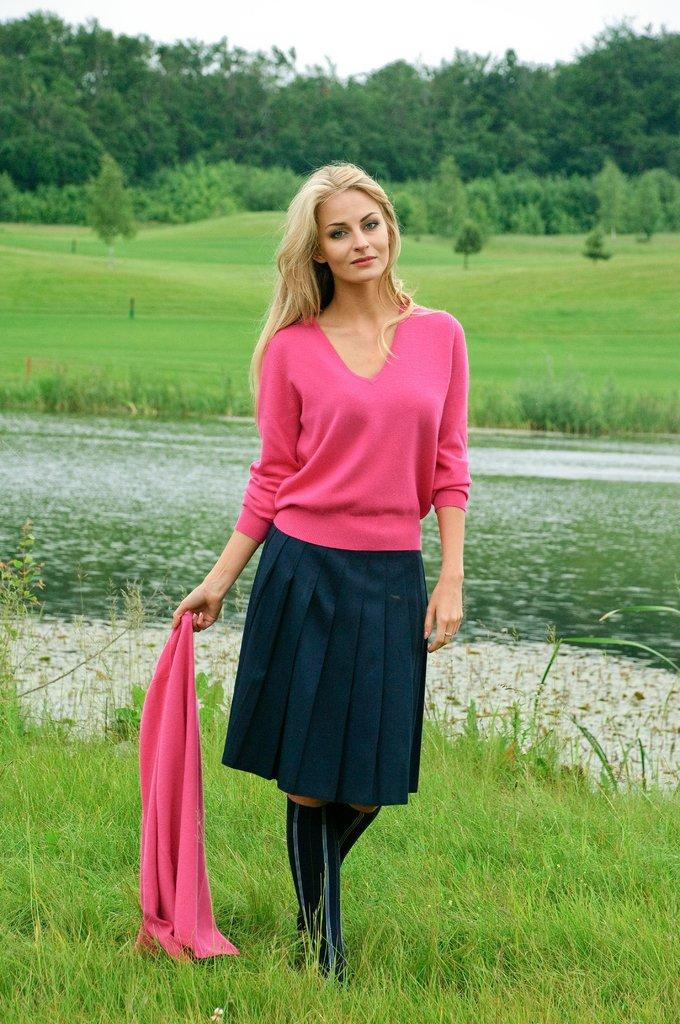What is the main subject of the image? There is a woman in the image. What is the woman doing in the image? The woman is standing in the image. What is the woman holding in her hand? The woman is holding a pink cloth in her hand. What can be seen in the background of the image? Water, grass, trees, and the sky are visible in the background of the image. What type of reason does the dog give for not wanting to go for a walk in the image? There is no dog present in the image, so it is not possible to determine any reasons for not wanting to go for a walk. 